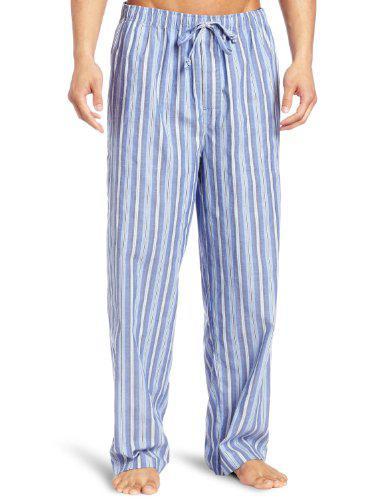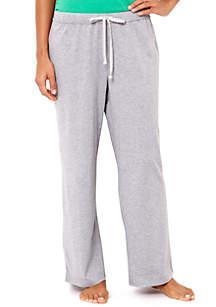The first image is the image on the left, the second image is the image on the right. For the images displayed, is the sentence "There are two pairs of grey athletic pants." factually correct? Answer yes or no. No. 